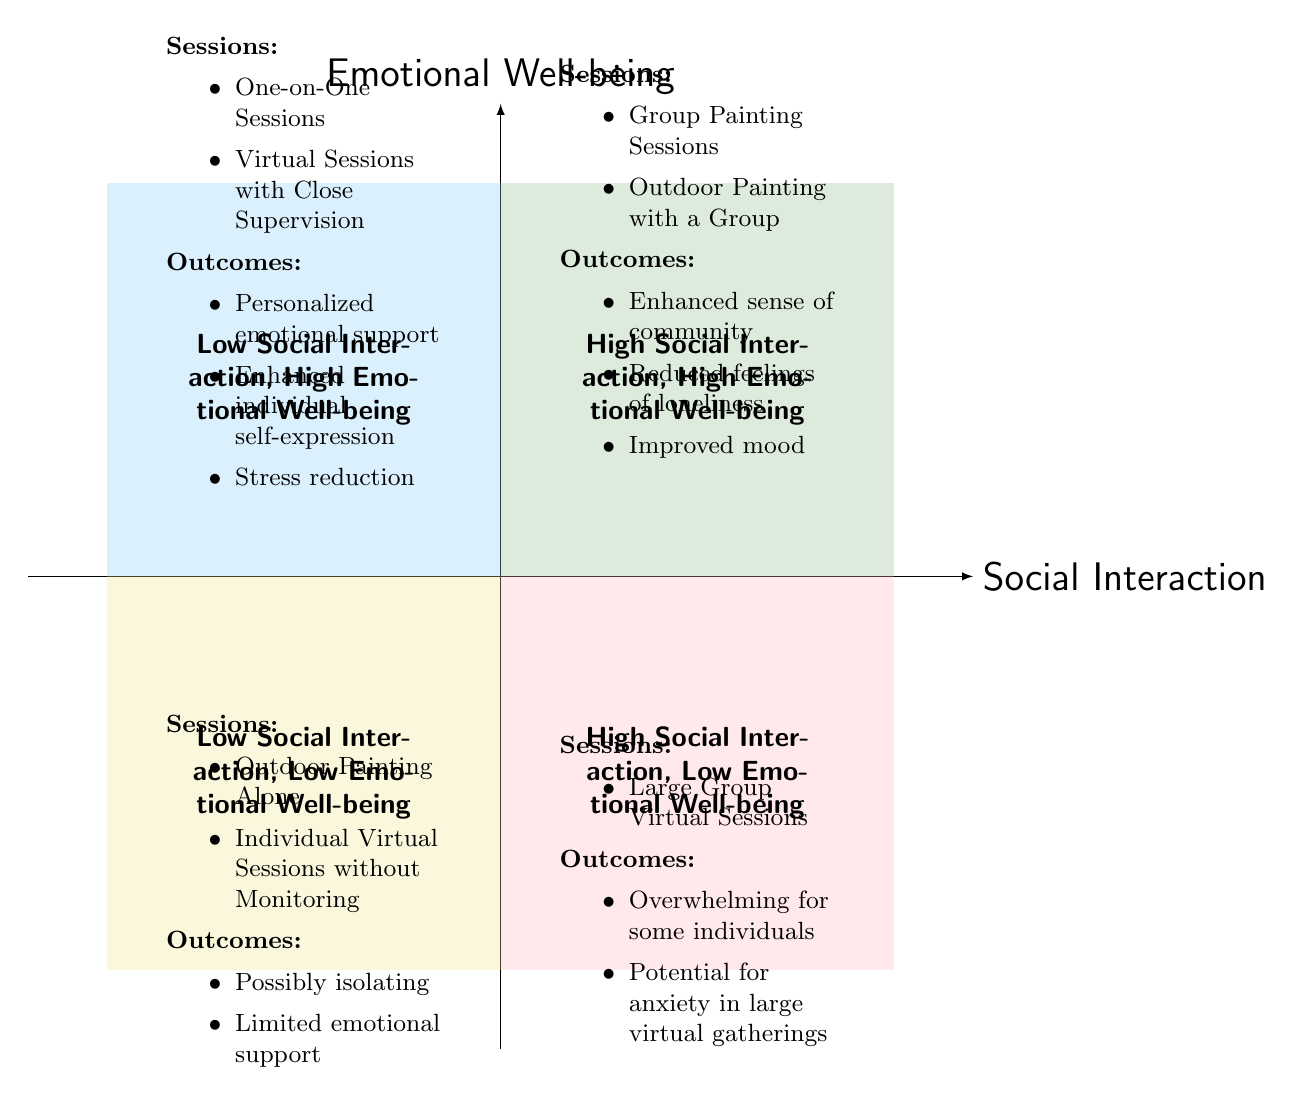What types of sessions are in the "High Social Interaction, High Emotional Well-being" quadrant? The diagram indicates that the types of sessions in this quadrant are "Group Painting Sessions" and "Outdoor Painting with a Group."
Answer: Group Painting Sessions, Outdoor Painting with a Group What are the emotional outcomes listed in the "Low Social Interaction, High Emotional Well-being" quadrant? The emotional outcomes in this quadrant are "Personalized emotional support," "Enhanced individual self-expression," and "Stress reduction."
Answer: Personalized emotional support, Enhanced individual self-expression, Stress reduction How many types of sessions are mentioned in the "High Social Interaction, Low Emotional Well-being" quadrant? This quadrant lists one type of session, which is "Large Group Virtual Sessions."
Answer: 1 Which quadrant has the outcome "Possibly isolating"? The "Low Social Interaction, Low Emotional Well-being" quadrant contains this outcome.
Answer: Low Social Interaction, Low Emotional Well-being What is the main reason listed for the "High Social Interaction, Low Emotional Well-being" quadrant? The main reason indicated is that large group virtual sessions can be overwhelming for some individuals, leading to potential anxiety.
Answer: Overwhelming for some individuals How does the "Low Social Interaction, Low Emotional Well-being" quadrant impact emotional support? The diagram states that this quadrant has "Limited emotional support," indicating reduced availability of emotional connections.
Answer: Limited emotional support Which session type is shared by both "High Social Interaction, High Emotional Well-being" and "Low Social Interaction, High Emotional Well-being" quadrants? Both quadrants do not share any session type; they have unique sessions specific to their emotional outcomes.
Answer: None What are the implications of having "Large Group Virtual Sessions" according to the diagram? The implications are that such sessions may be overwhelming and potentially lead to anxiety in large virtual gatherings for participants.
Answer: Overwhelming, Potential for anxiety 